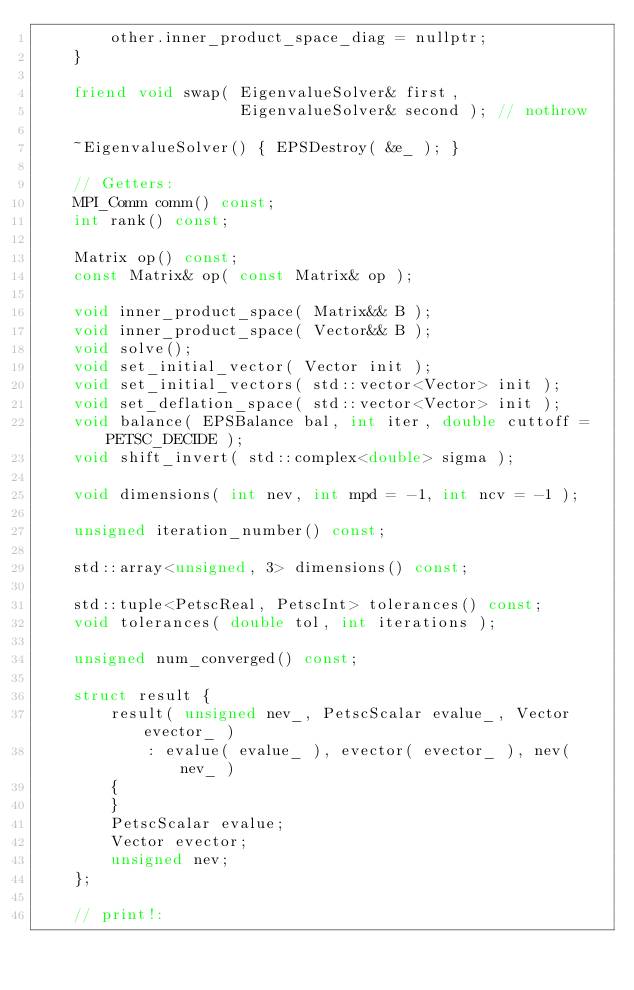Convert code to text. <code><loc_0><loc_0><loc_500><loc_500><_C++_>        other.inner_product_space_diag = nullptr;
    }

    friend void swap( EigenvalueSolver& first,
                      EigenvalueSolver& second ); // nothrow

    ~EigenvalueSolver() { EPSDestroy( &e_ ); }

    // Getters:
    MPI_Comm comm() const;
    int rank() const;

    Matrix op() const;
    const Matrix& op( const Matrix& op );

    void inner_product_space( Matrix&& B );
    void inner_product_space( Vector&& B );
    void solve();
    void set_initial_vector( Vector init );
    void set_initial_vectors( std::vector<Vector> init );
    void set_deflation_space( std::vector<Vector> init );
    void balance( EPSBalance bal, int iter, double cuttoff = PETSC_DECIDE );
    void shift_invert( std::complex<double> sigma );

    void dimensions( int nev, int mpd = -1, int ncv = -1 );

    unsigned iteration_number() const;

    std::array<unsigned, 3> dimensions() const;

    std::tuple<PetscReal, PetscInt> tolerances() const;
    void tolerances( double tol, int iterations );

    unsigned num_converged() const;

    struct result {
        result( unsigned nev_, PetscScalar evalue_, Vector evector_ )
            : evalue( evalue_ ), evector( evector_ ), nev( nev_ )
        {
        }
        PetscScalar evalue;
        Vector evector;
        unsigned nev;
    };

    // print!:</code> 